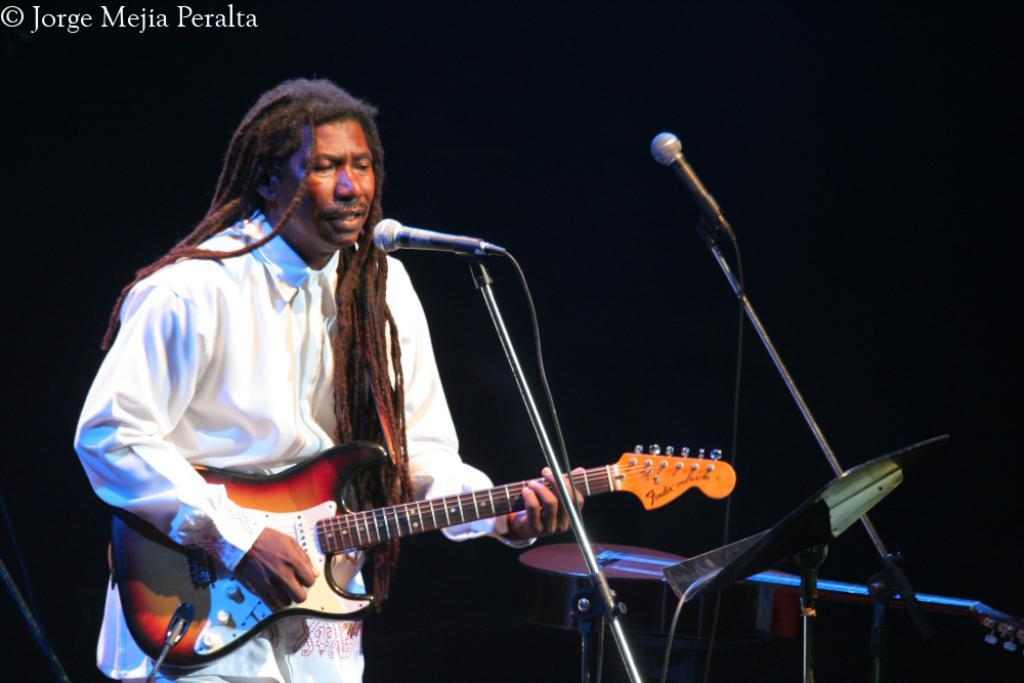What objects are present in the image related to sound recording? There are two microphones in the image. Who is present in the image? There is a man in the image. What is the man wearing? The man is dressed in white. What instrument is the man holding? The man is holding a guitar. What type of farm animals can be seen in the image? There are no farm animals present in the image. What watch is the man wearing in the image? The man is not wearing a watch in the image. 